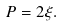Convert formula to latex. <formula><loc_0><loc_0><loc_500><loc_500>P = 2 \xi .</formula> 